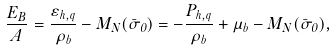Convert formula to latex. <formula><loc_0><loc_0><loc_500><loc_500>\frac { E _ { B } } { A } = \frac { \varepsilon _ { h , q } } { \rho _ { b } } - M _ { N } ( \bar { \sigma } _ { 0 } ) = - \frac { P _ { h , q } } { \rho _ { b } } + \mu _ { b } - M _ { N } ( \bar { \sigma } _ { 0 } ) ,</formula> 